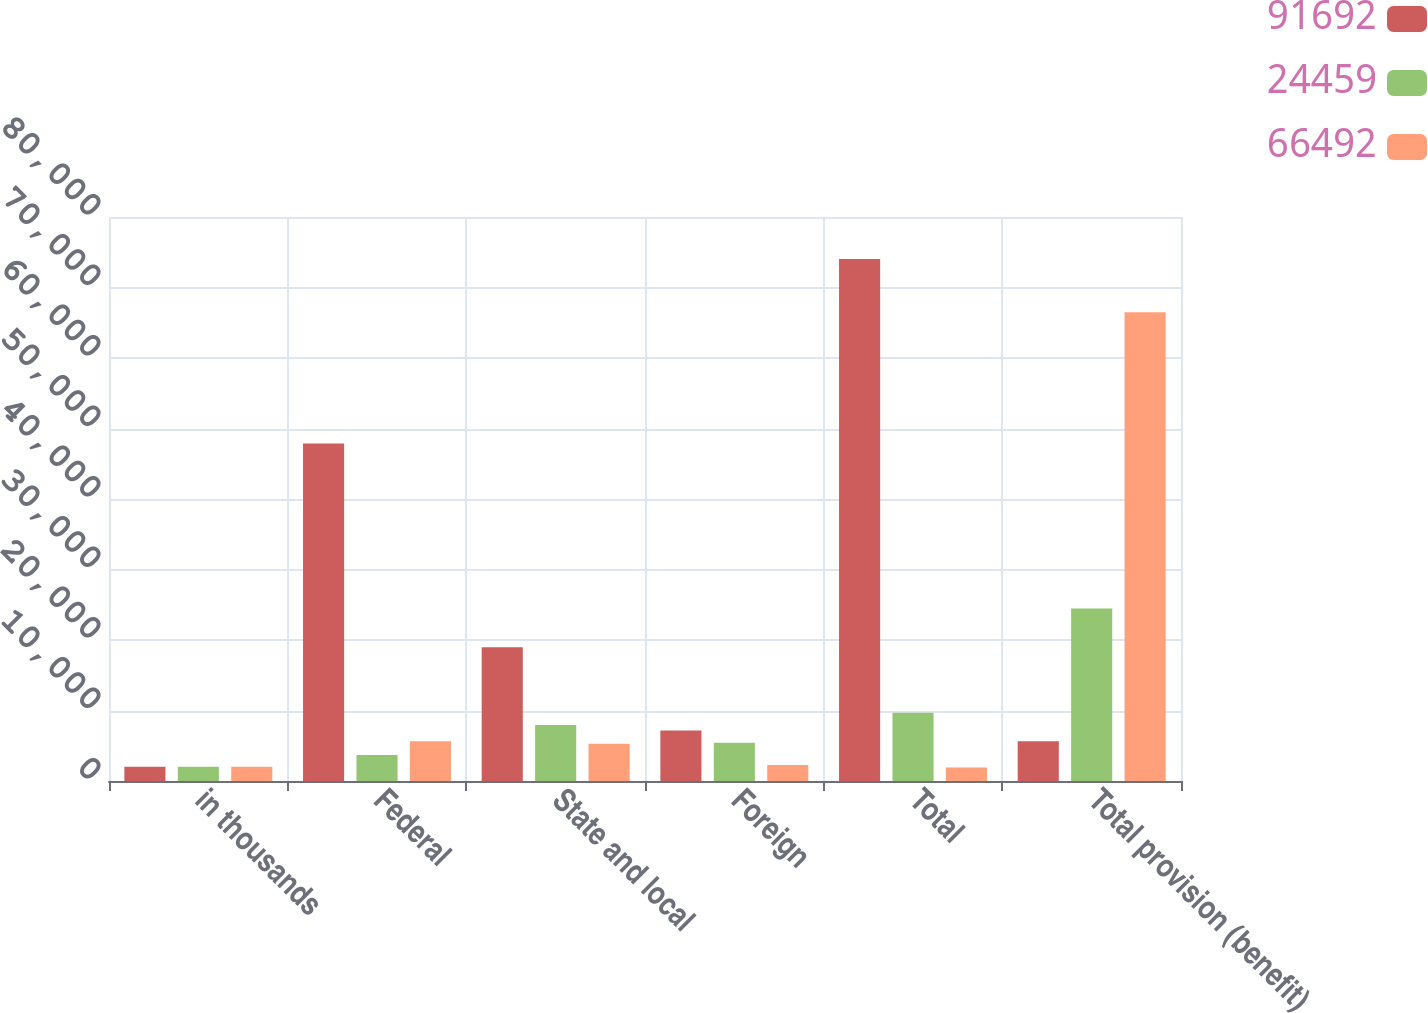Convert chart to OTSL. <chart><loc_0><loc_0><loc_500><loc_500><stacked_bar_chart><ecel><fcel>in thousands<fcel>Federal<fcel>State and local<fcel>Foreign<fcel>Total<fcel>Total provision (benefit)<nl><fcel>91692<fcel>2014<fcel>47882<fcel>18983<fcel>7174<fcel>74039<fcel>5631<nl><fcel>24459<fcel>2013<fcel>3691<fcel>7941<fcel>5423<fcel>9673<fcel>24459<nl><fcel>66492<fcel>2012<fcel>5631<fcel>5271<fcel>2273<fcel>1913<fcel>66492<nl></chart> 